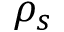<formula> <loc_0><loc_0><loc_500><loc_500>\rho _ { s }</formula> 